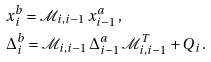<formula> <loc_0><loc_0><loc_500><loc_500>& x _ { i } ^ { b } = \mathcal { M } _ { i , i - 1 } \, x _ { i - 1 } ^ { a } \, , \\ & \Delta _ { i } ^ { b } = \mathcal { M } _ { i , i - 1 } \, \Delta _ { i - 1 } ^ { a } \, \mathcal { M } _ { i , i - 1 } ^ { T } + Q _ { i } \, .</formula> 